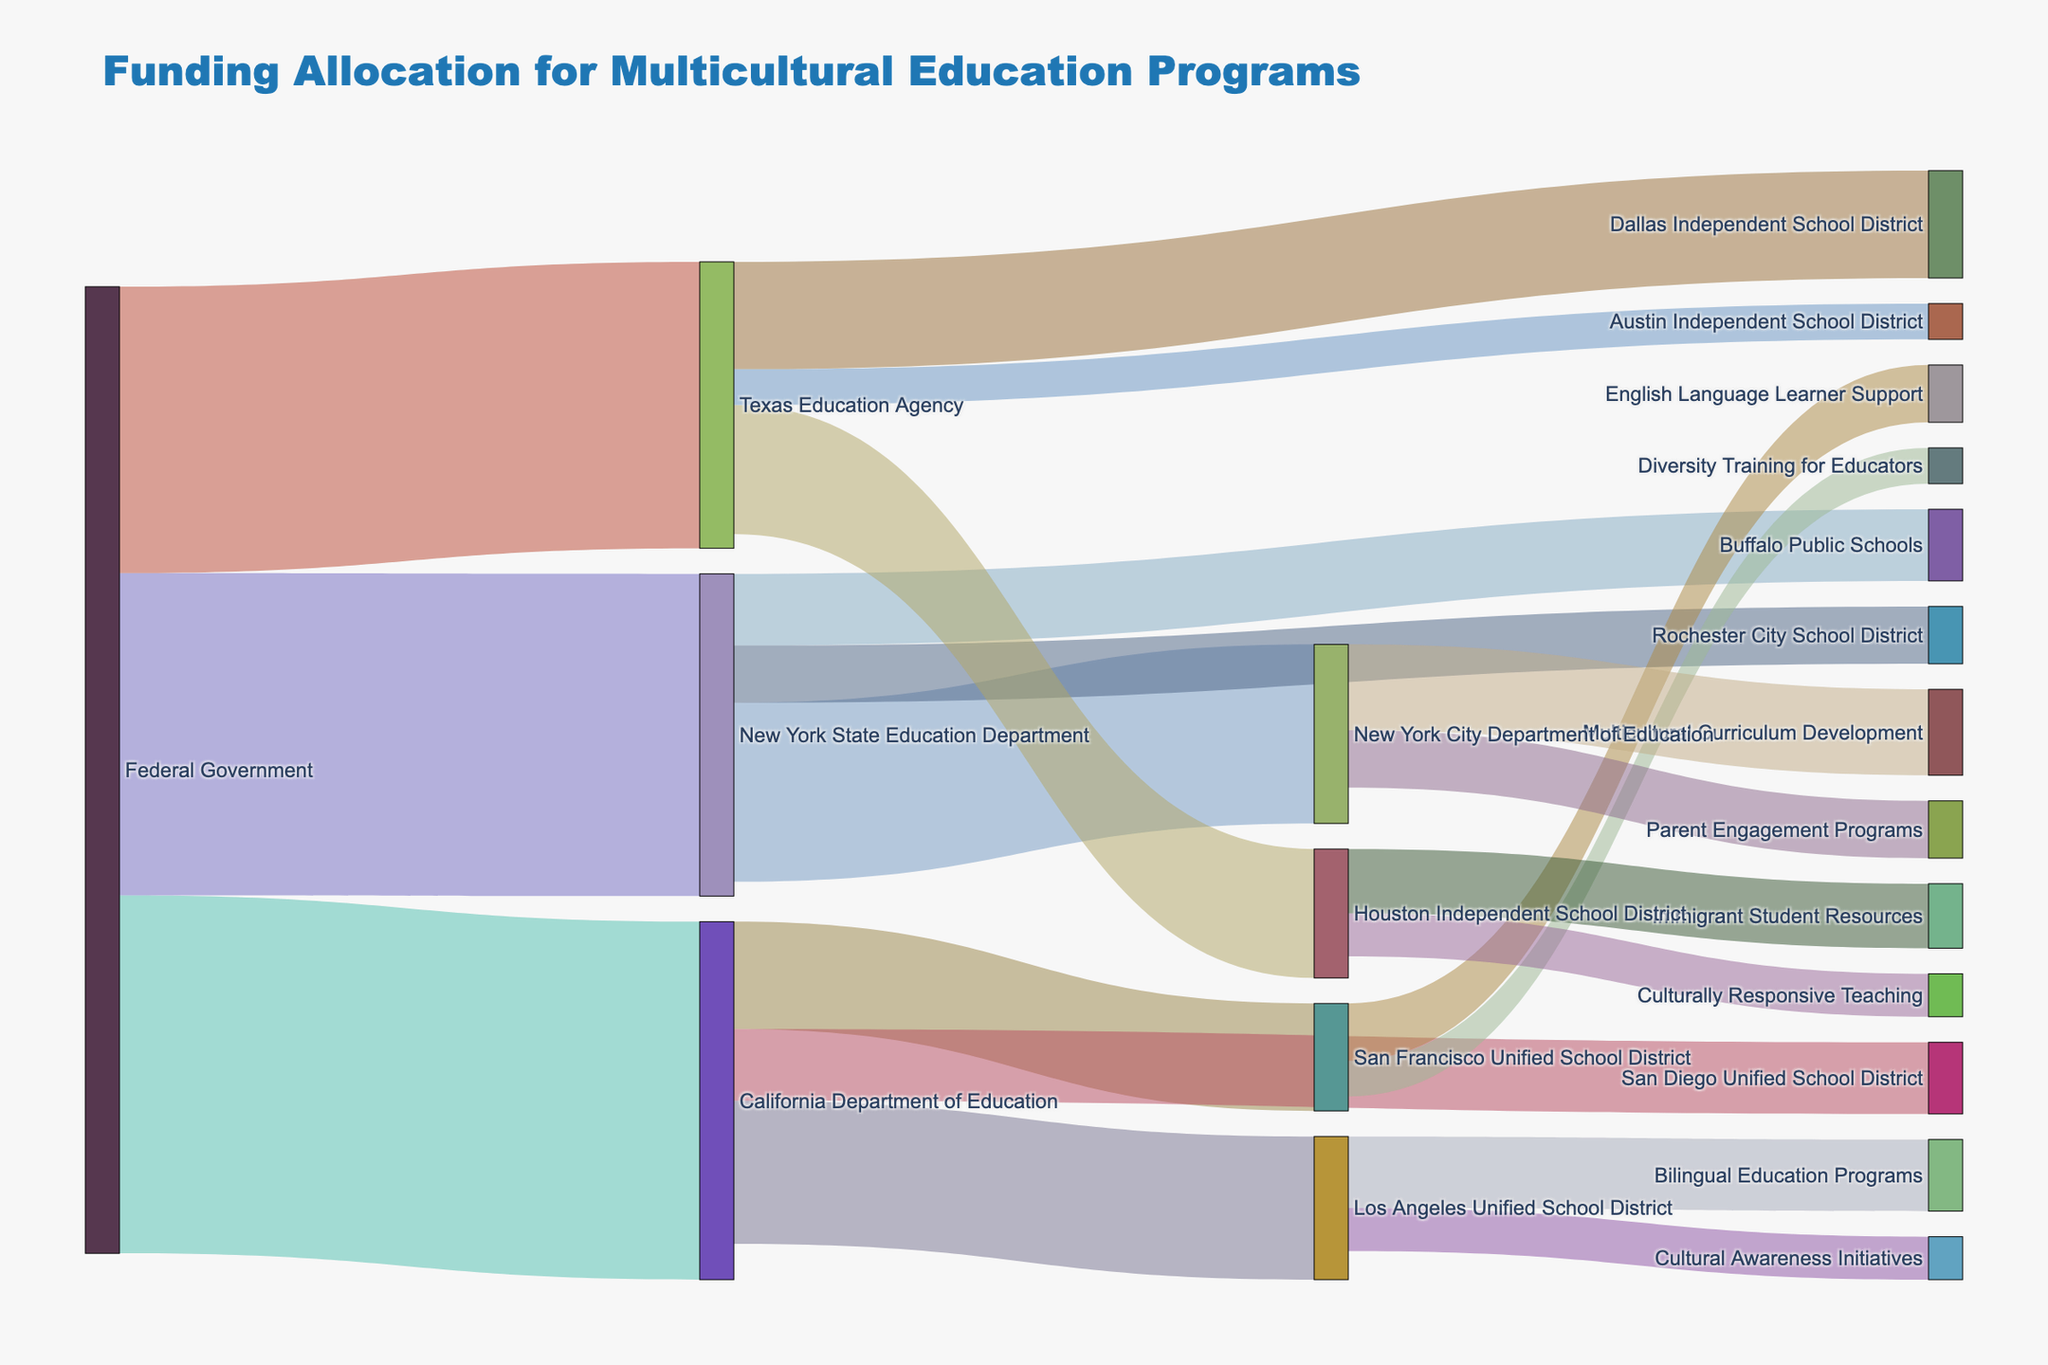How much funding does the Federal Government allocate to the Texas Education Agency? First, identify the link from the Federal Government to the Texas Education Agency in the Sankey diagram. Then, locate the value associated with that link.
Answer: 4000000 Which school district in California receives the highest amount of funding from the California Department of Education? Look at the links extending from the California Department of Education to various school districts in California. Compare the values and identify the highest one.
Answer: Los Angeles Unified School District What is the total amount of funding allocated by the New York State Education Department? Find all the links originating from the New York State Education Department. Sum the values of these links: 2500000 (NYC DOE) + 1000000 (Buffalo) + 800000 (Rochester) = 4300000.
Answer: 4300000 Compare the funding received by the San Francisco Unified School District for English Language Learner Support and Diversity Training for Educators. Which program receives more funding? Identify the links from the San Francisco Unified School District to the English Language Learner Support and Diversity Training for Educators. Compare the values: 800000 (ELL Support) vs 500000 (Diversity Training).
Answer: English Language Learner Support How much funding does the Los Angeles Unified School District channel into Cultural Awareness Initiatives? Locate the link from the Los Angeles Unified School District to Cultural Awareness Initiatives and note the value associated with it.
Answer: 600000 What is the sum of the funds received by the Houston Independent School District from the Texas Education Agency and how are these funds allocated among different programs? Identify the link from the Texas Education Agency to the Houston Independent School District. Then, sum the allocations to Immigrant Student Resources (900000) and Culturally Responsive Teaching (600000): 900000 + 600000 = 1500000.
Answer: 1500000 Compare the total funding allocated to the New York City Department of Education and the Houston Independent School District. Which one receives more? Sum the values of funding to the New York City DOE (2500000) and the Houston ISD (1800000). Compare: 2500000 > 1800000.
Answer: New York City Department of Education Which program under the New York City Department of Education receives the highest amount of funding? Identify the links extending from the New York City Department of Education and compare their values: Multicultural Curriculum Development (1200000) vs Parent Engagement Programs (800000).
Answer: Multicultural Curriculum Development 